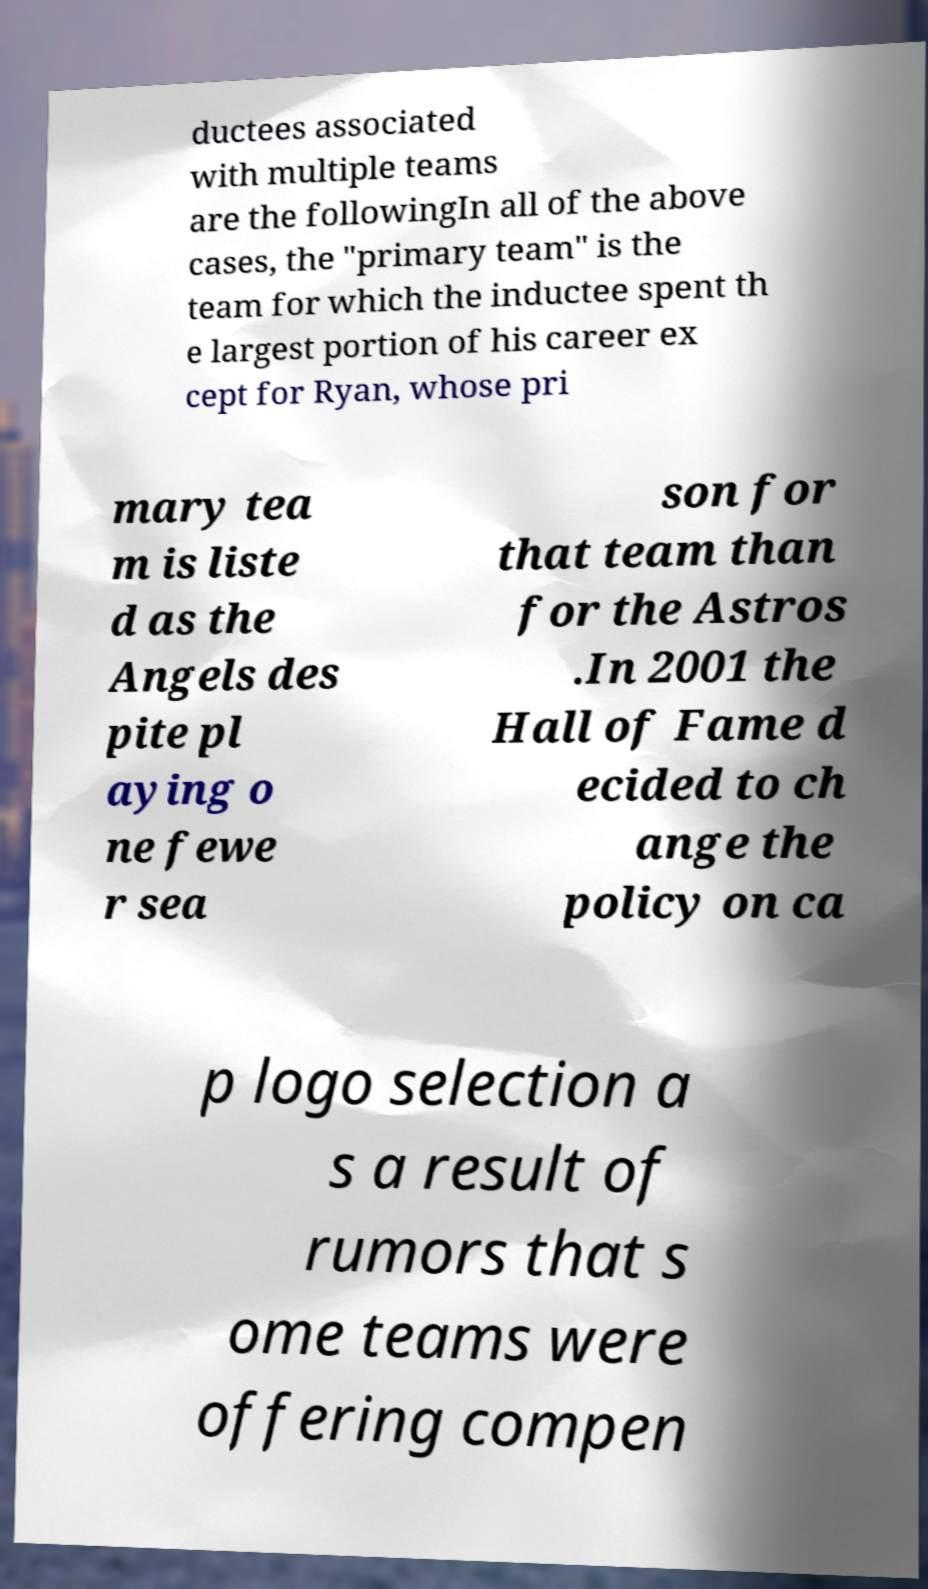Please read and relay the text visible in this image. What does it say? ductees associated with multiple teams are the followingIn all of the above cases, the "primary team" is the team for which the inductee spent th e largest portion of his career ex cept for Ryan, whose pri mary tea m is liste d as the Angels des pite pl aying o ne fewe r sea son for that team than for the Astros .In 2001 the Hall of Fame d ecided to ch ange the policy on ca p logo selection a s a result of rumors that s ome teams were offering compen 